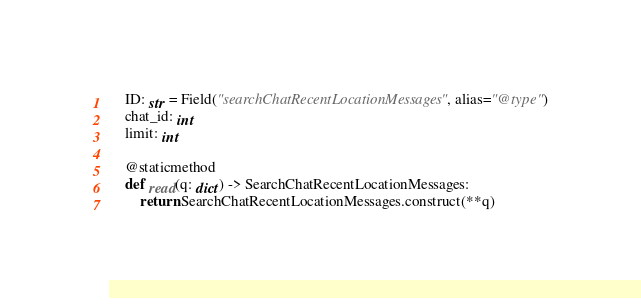<code> <loc_0><loc_0><loc_500><loc_500><_Python_>    ID: str = Field("searchChatRecentLocationMessages", alias="@type")
    chat_id: int
    limit: int

    @staticmethod
    def read(q: dict) -> SearchChatRecentLocationMessages:
        return SearchChatRecentLocationMessages.construct(**q)
</code> 